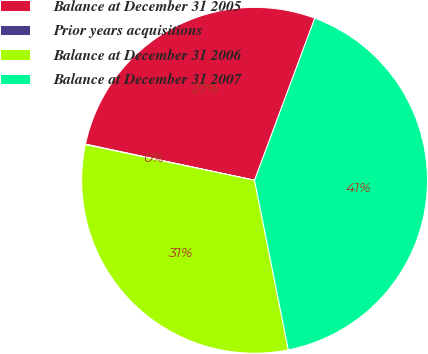<chart> <loc_0><loc_0><loc_500><loc_500><pie_chart><fcel>Balance at December 31 2005<fcel>Prior years acquisitions<fcel>Balance at December 31 2006<fcel>Balance at December 31 2007<nl><fcel>27.31%<fcel>0.05%<fcel>31.43%<fcel>41.21%<nl></chart> 